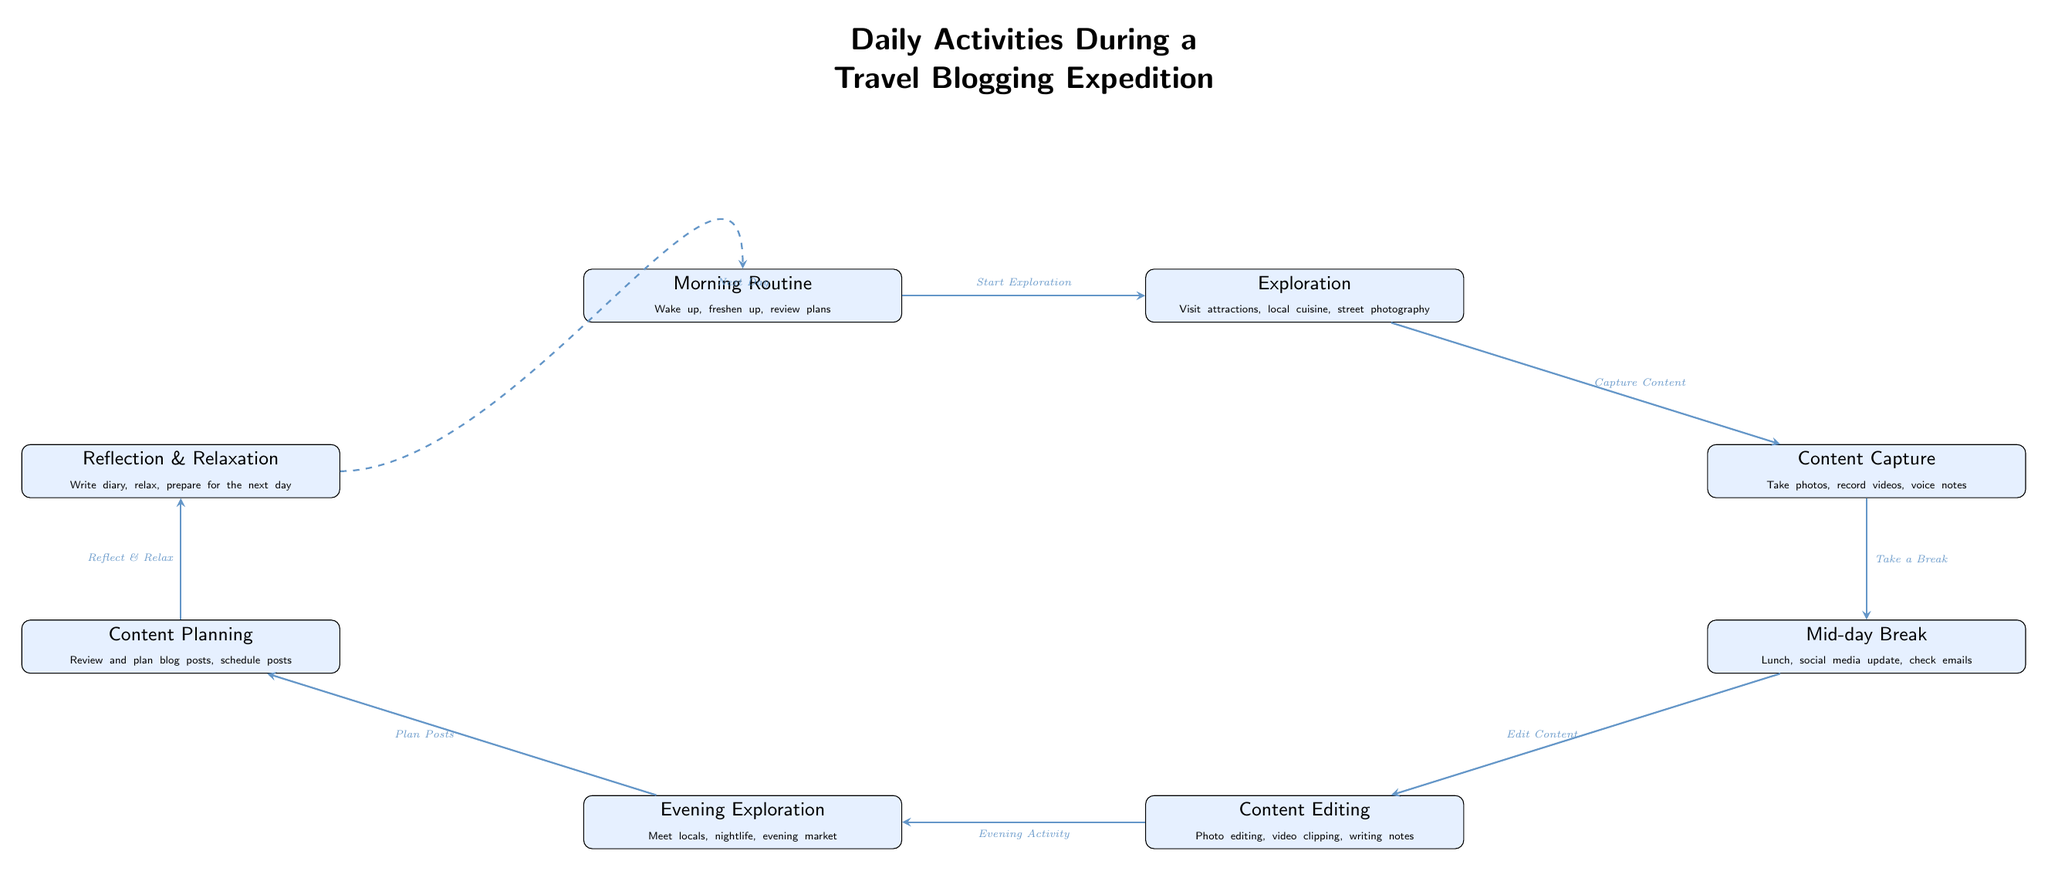What is the first activity listed in the diagram? The diagram presents a sequence of daily activities, with the first node labeled "Morning Routine," indicating that this is the initial activity during a travel blogging expedition.
Answer: Morning Routine How many total activities are represented in the diagram? By examining each distinct activity node in the diagram, we count a total of eight (8) key activities outlined in the flow.
Answer: 8 What does "Mid-day Break" lead to? According to the flow of the diagram, the "Mid-day Break" is followed by the "Content Editing" activity, which signifies what occurs after this break.
Answer: Content Editing What is the main purpose of the "Evening Exploration" activity? The "Evening Exploration" activity is designed to facilitate interaction with locals and experience nightlife, as outlined in the description associated with this activity.
Answer: Meet locals, nightlife Which activity connects "Content Capture" and "Content Editing"? The diagram clearly connects "Content Capture" directly to "Mid-day Break," which is the intermediate activity leading to "Content Editing."
Answer: Mid-day Break Which activity is the last step before starting the next day? The diagram indicates that "Reflection & Relaxation" leads back to the "Morning Routine," making it the last step before the following day's activities commence.
Answer: Reflection & Relaxation How does "Content Planning" relate to "Evening Exploration"? The diagram illustrates that "Content Planning" follows "Evening Exploration," meaning that after engaging in evening activities, the blogger plans their content.
Answer: Plan Posts What type of relationship exists between "Reflection & Relaxation" and "Morning Routine"? The relationship is circular, as "Reflection & Relaxation" leads back to "Morning Routine," establishing a cycle in daily activities for the travel blogger.
Answer: Circular relationship 